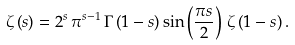<formula> <loc_0><loc_0><loc_500><loc_500>\zeta \left ( s \right ) = 2 ^ { s } \, \pi ^ { s - 1 } \, \Gamma \left ( { 1 - s } \right ) \sin \left ( { \frac { \pi s } { 2 } } \right ) \, \zeta \left ( { 1 - s } \right ) .</formula> 